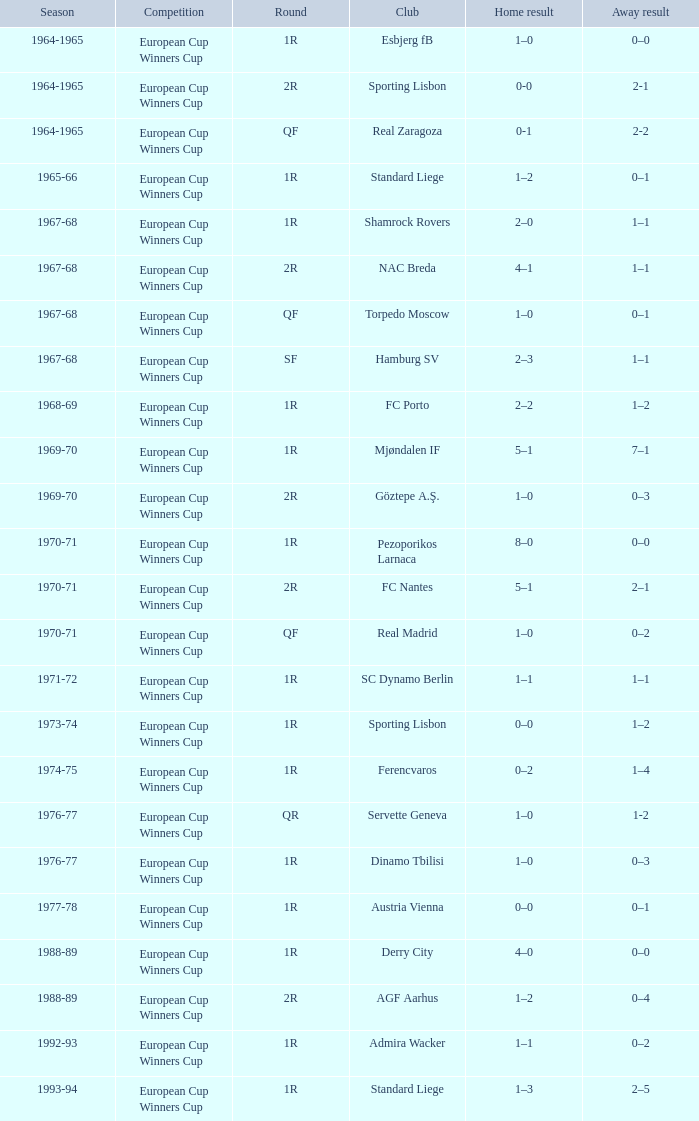Home victory of 1–0, and an away victory of 0–1 involves which squad? Torpedo Moscow. 